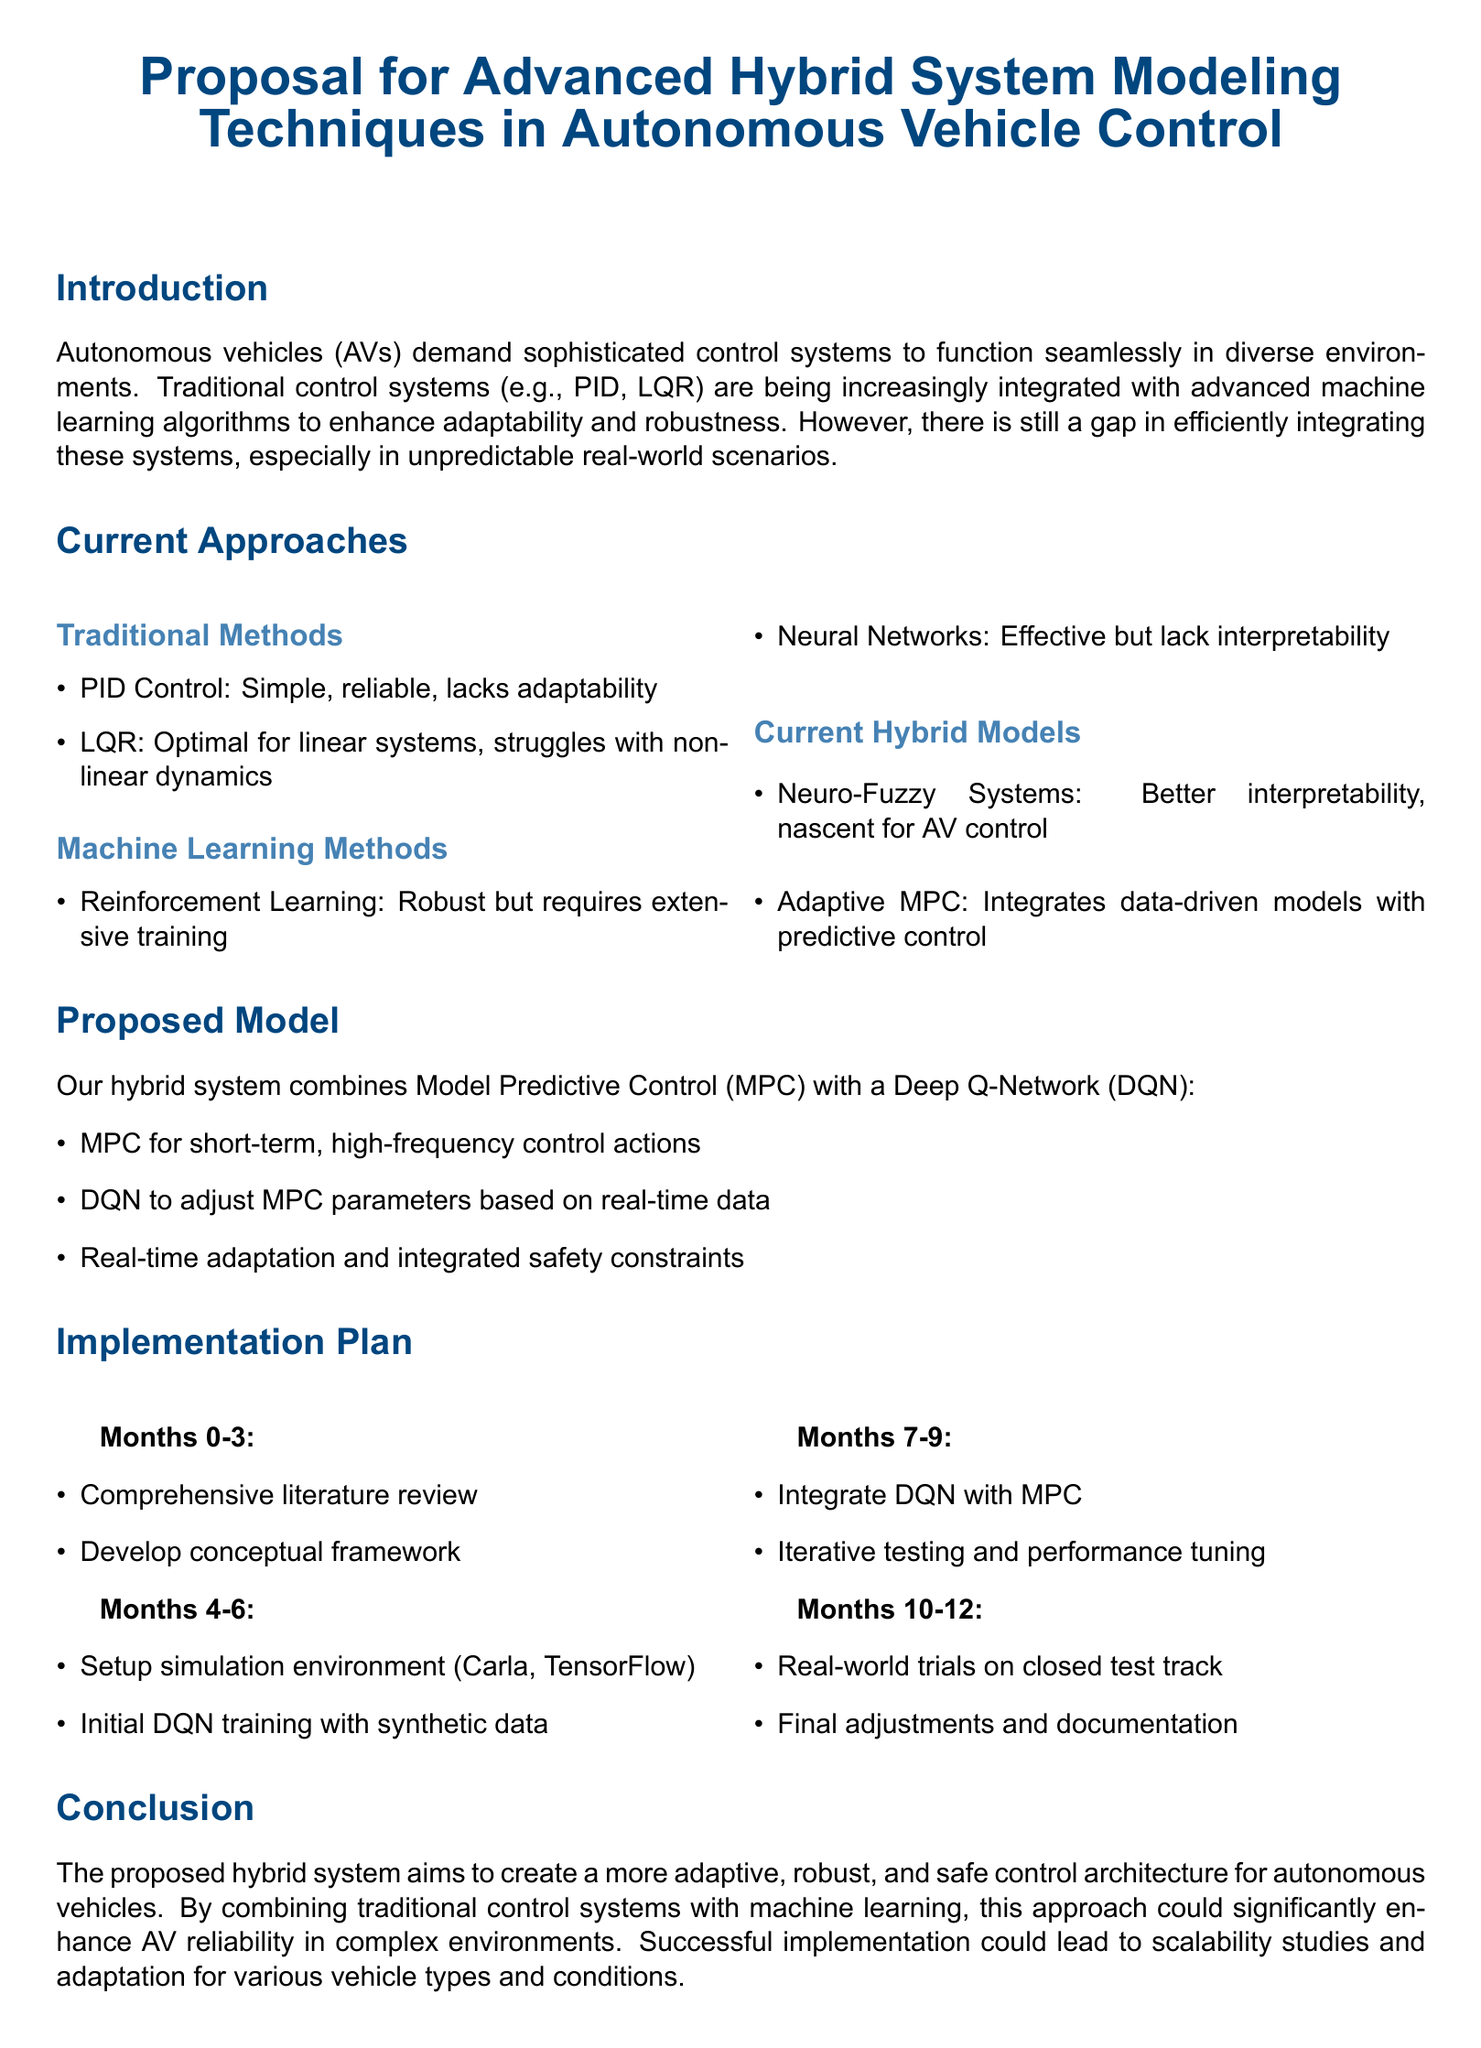What is the main goal of the proposal? The main goal is to create a more adaptive, robust, and safe control architecture for autonomous vehicles.
Answer: More adaptive, robust, and safe control architecture for autonomous vehicles What are the two primary components of the proposed hybrid system? The two primary components are Model Predictive Control and Deep Q-Network.
Answer: Model Predictive Control and Deep Q-Network How long is the entire implementation plan proposed to take? The implementation plan is divided into four phases, each lasting three months, making the total duration twelve months.
Answer: Twelve months Which machine learning method requires extensive training as mentioned in the document? The machine learning method that requires extensive training is Reinforcement Learning.
Answer: Reinforcement Learning During which months is the initial DQN training scheduled? The initial DQN training is scheduled for months four to six.
Answer: Months four to six What is the first task listed in the implementation plan? The first task listed in the implementation plan is a comprehensive literature review.
Answer: Comprehensive literature review What type of control does MPC provide according to the proposal? MPC provides short-term, high-frequency control actions.
Answer: Short-term, high-frequency control actions What is the major challenge addressed by this proposal? The major challenge addressed is the efficient integration of control systems in unpredictable real-world scenarios.
Answer: Efficient integration of control systems in unpredictable real-world scenarios 